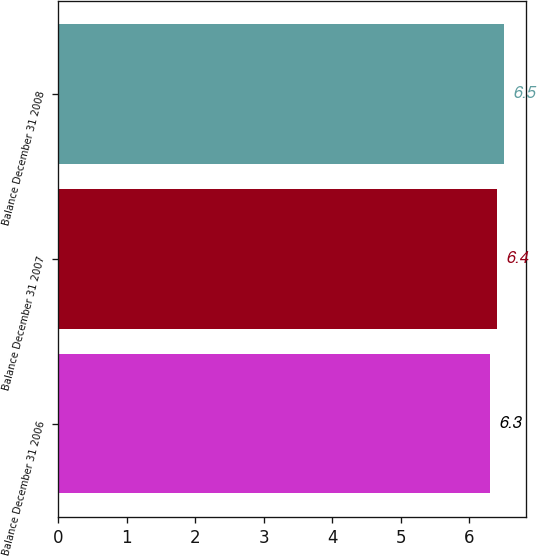Convert chart. <chart><loc_0><loc_0><loc_500><loc_500><bar_chart><fcel>Balance December 31 2006<fcel>Balance December 31 2007<fcel>Balance December 31 2008<nl><fcel>6.3<fcel>6.4<fcel>6.5<nl></chart> 